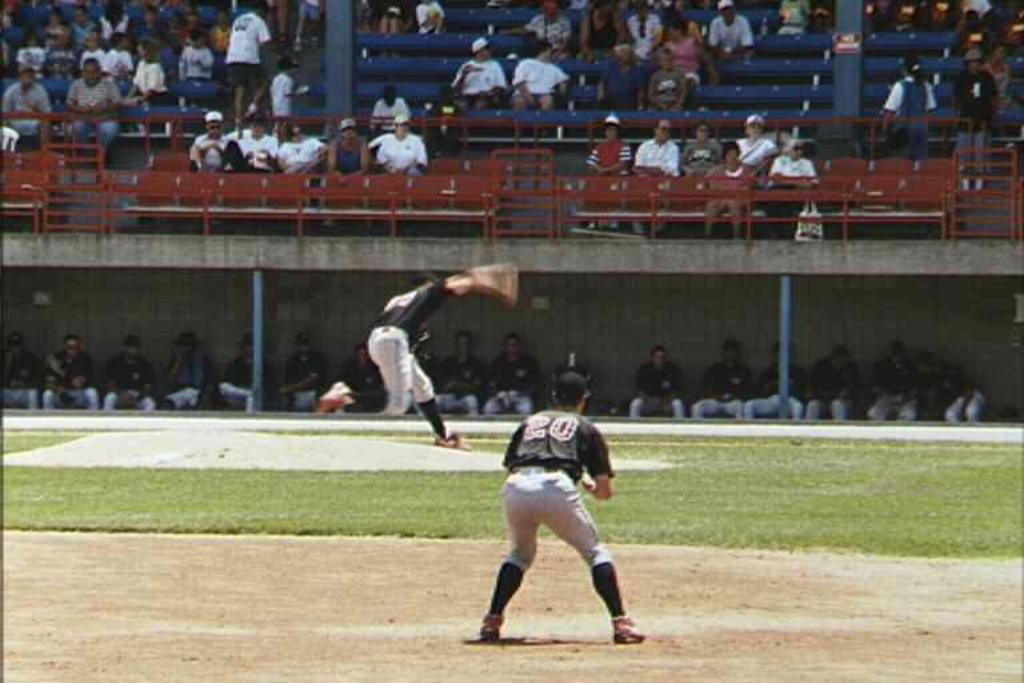<image>
Summarize the visual content of the image. player number 20 gets ready to catch a ball as the pitcher throws it 